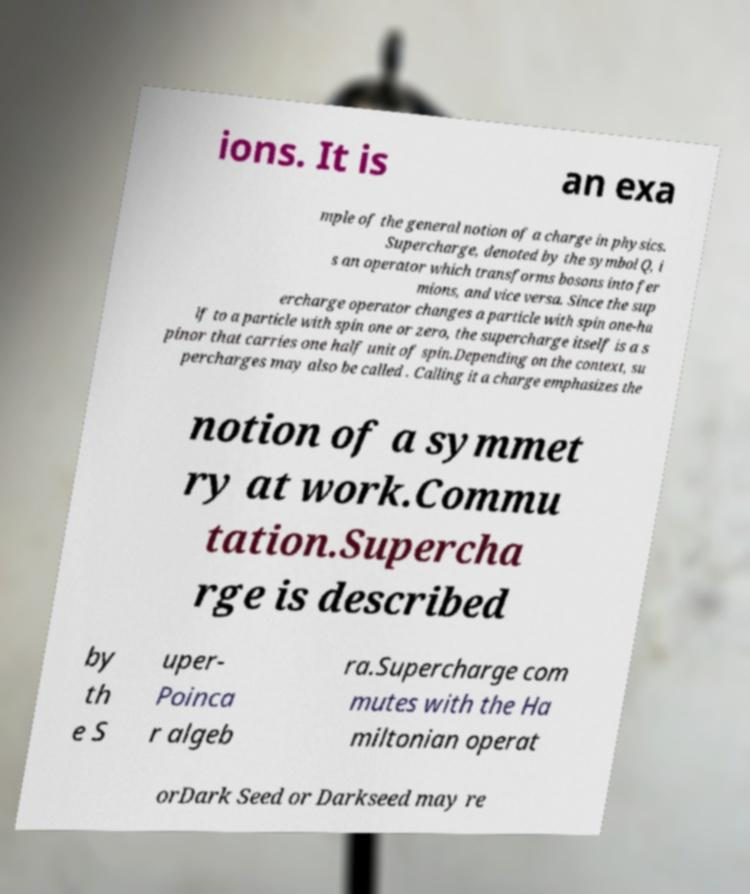Can you read and provide the text displayed in the image?This photo seems to have some interesting text. Can you extract and type it out for me? ions. It is an exa mple of the general notion of a charge in physics. Supercharge, denoted by the symbol Q, i s an operator which transforms bosons into fer mions, and vice versa. Since the sup ercharge operator changes a particle with spin one-ha lf to a particle with spin one or zero, the supercharge itself is a s pinor that carries one half unit of spin.Depending on the context, su percharges may also be called . Calling it a charge emphasizes the notion of a symmet ry at work.Commu tation.Supercha rge is described by th e S uper- Poinca r algeb ra.Supercharge com mutes with the Ha miltonian operat orDark Seed or Darkseed may re 